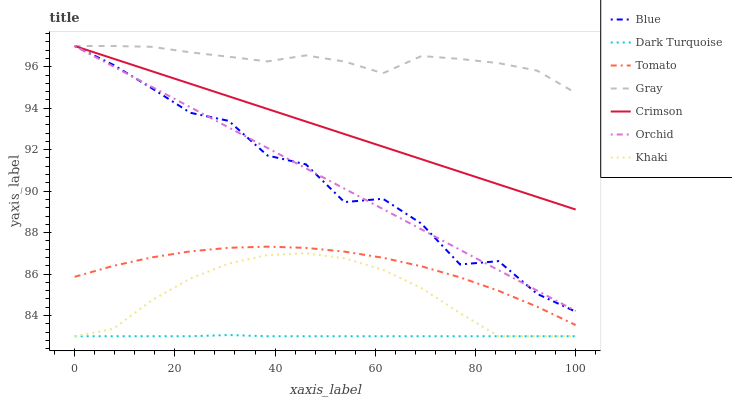Does Dark Turquoise have the minimum area under the curve?
Answer yes or no. Yes. Does Gray have the maximum area under the curve?
Answer yes or no. Yes. Does Tomato have the minimum area under the curve?
Answer yes or no. No. Does Tomato have the maximum area under the curve?
Answer yes or no. No. Is Crimson the smoothest?
Answer yes or no. Yes. Is Blue the roughest?
Answer yes or no. Yes. Is Tomato the smoothest?
Answer yes or no. No. Is Tomato the roughest?
Answer yes or no. No. Does Khaki have the lowest value?
Answer yes or no. Yes. Does Tomato have the lowest value?
Answer yes or no. No. Does Orchid have the highest value?
Answer yes or no. Yes. Does Tomato have the highest value?
Answer yes or no. No. Is Khaki less than Orchid?
Answer yes or no. Yes. Is Orchid greater than Dark Turquoise?
Answer yes or no. Yes. Does Gray intersect Orchid?
Answer yes or no. Yes. Is Gray less than Orchid?
Answer yes or no. No. Is Gray greater than Orchid?
Answer yes or no. No. Does Khaki intersect Orchid?
Answer yes or no. No. 